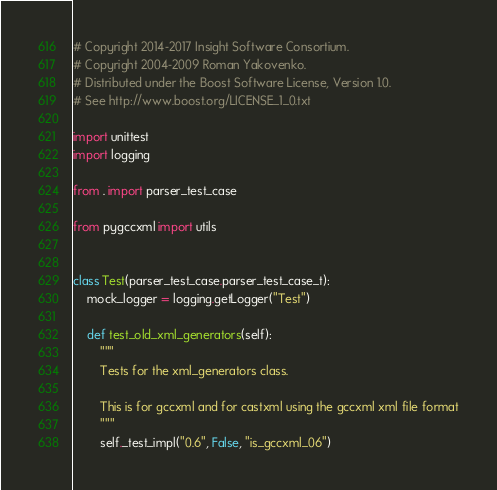<code> <loc_0><loc_0><loc_500><loc_500><_Python_># Copyright 2014-2017 Insight Software Consortium.
# Copyright 2004-2009 Roman Yakovenko.
# Distributed under the Boost Software License, Version 1.0.
# See http://www.boost.org/LICENSE_1_0.txt

import unittest
import logging

from . import parser_test_case

from pygccxml import utils


class Test(parser_test_case.parser_test_case_t):
    mock_logger = logging.getLogger("Test")

    def test_old_xml_generators(self):
        """
        Tests for the xml_generators class.

        This is for gccxml and for castxml using the gccxml xml file format
        """
        self._test_impl("0.6", False, "is_gccxml_06")</code> 